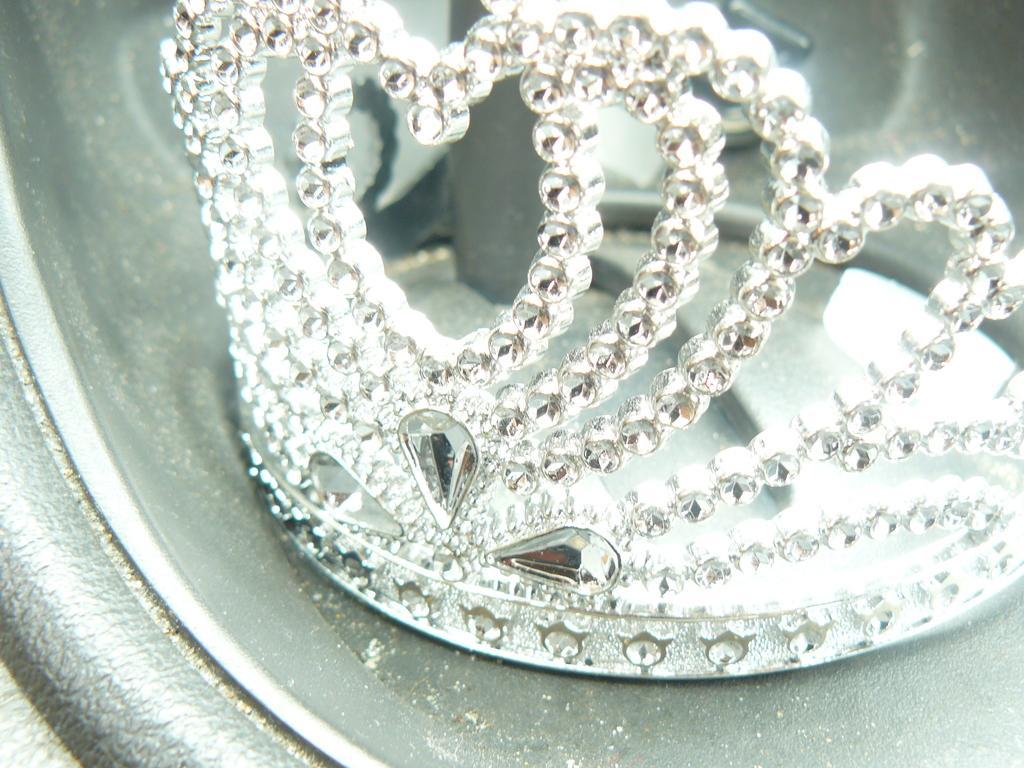How would you summarize this image in a sentence or two? In this image we can see a crown placed in a container. 